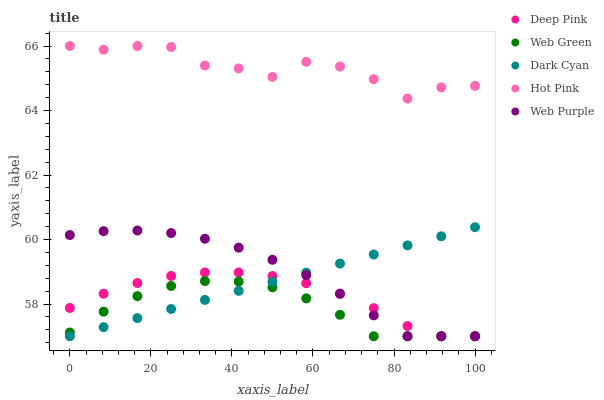Does Web Green have the minimum area under the curve?
Answer yes or no. Yes. Does Hot Pink have the maximum area under the curve?
Answer yes or no. Yes. Does Web Purple have the minimum area under the curve?
Answer yes or no. No. Does Web Purple have the maximum area under the curve?
Answer yes or no. No. Is Dark Cyan the smoothest?
Answer yes or no. Yes. Is Hot Pink the roughest?
Answer yes or no. Yes. Is Web Purple the smoothest?
Answer yes or no. No. Is Web Purple the roughest?
Answer yes or no. No. Does Dark Cyan have the lowest value?
Answer yes or no. Yes. Does Hot Pink have the lowest value?
Answer yes or no. No. Does Hot Pink have the highest value?
Answer yes or no. Yes. Does Web Purple have the highest value?
Answer yes or no. No. Is Deep Pink less than Hot Pink?
Answer yes or no. Yes. Is Hot Pink greater than Web Purple?
Answer yes or no. Yes. Does Web Green intersect Deep Pink?
Answer yes or no. Yes. Is Web Green less than Deep Pink?
Answer yes or no. No. Is Web Green greater than Deep Pink?
Answer yes or no. No. Does Deep Pink intersect Hot Pink?
Answer yes or no. No. 